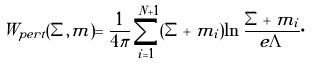<formula> <loc_0><loc_0><loc_500><loc_500>\tilde { W } _ { p e r t } ( \Sigma , m ) = \frac { 1 } { 4 \pi } \sum _ { i = 1 } ^ { N + 1 } ( \Sigma + m _ { i } ) \ln \frac { \Sigma + m _ { i } } { e \Lambda } \cdot</formula> 